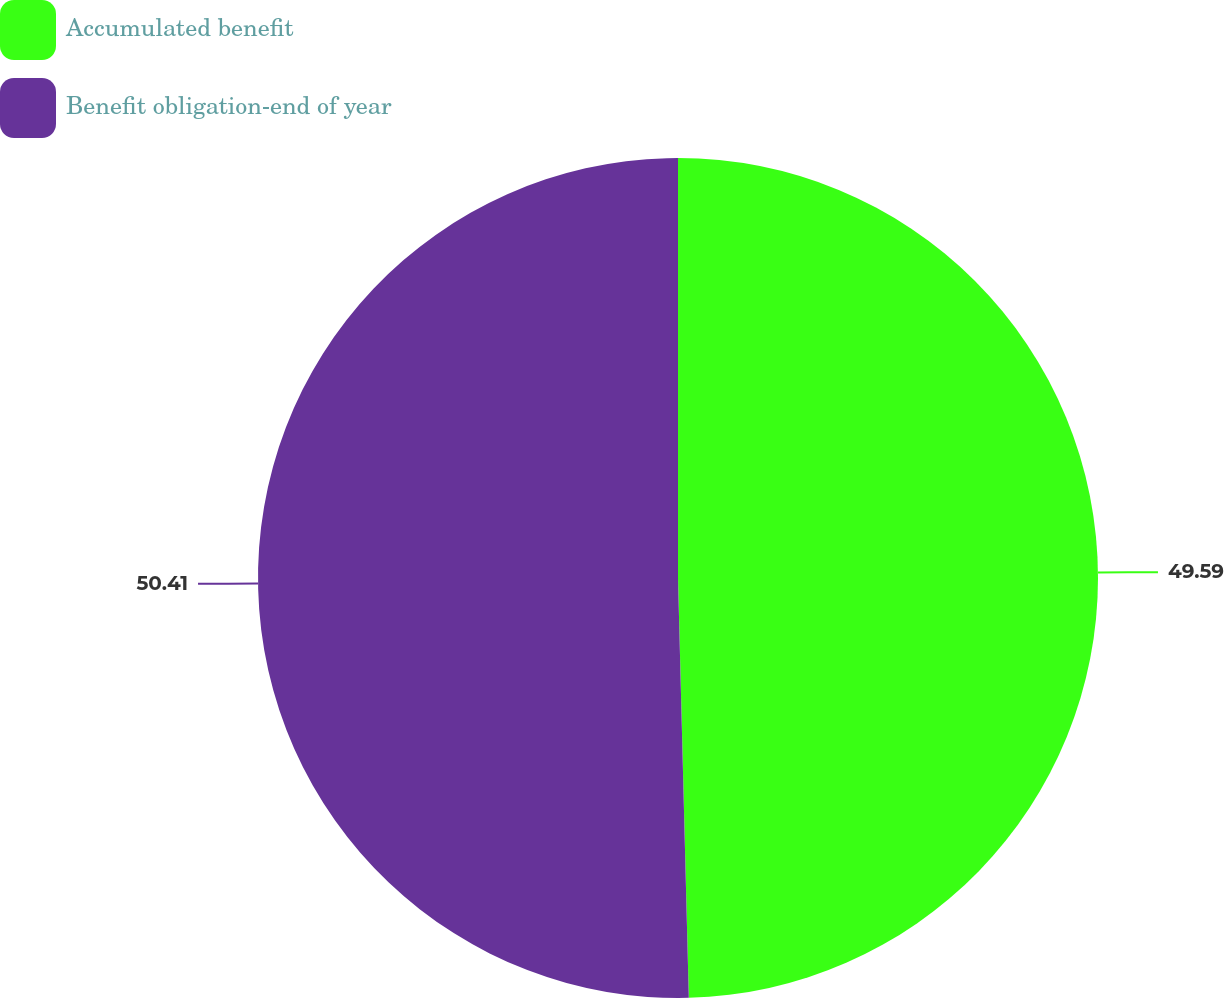Convert chart to OTSL. <chart><loc_0><loc_0><loc_500><loc_500><pie_chart><fcel>Accumulated benefit<fcel>Benefit obligation-end of year<nl><fcel>49.59%<fcel>50.41%<nl></chart> 